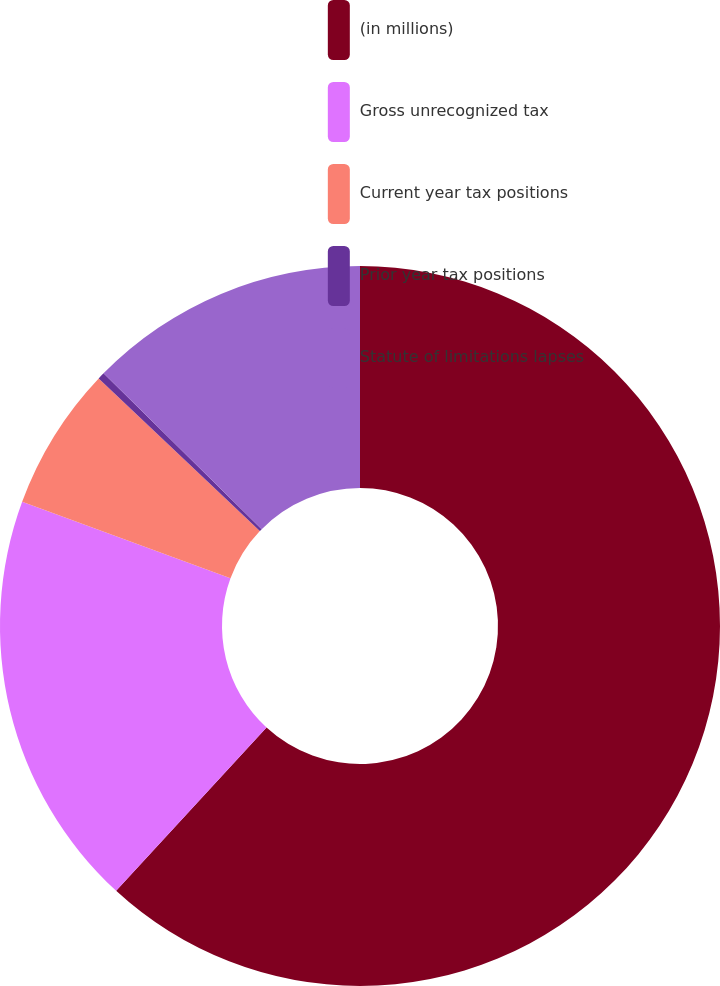Convert chart to OTSL. <chart><loc_0><loc_0><loc_500><loc_500><pie_chart><fcel>(in millions)<fcel>Gross unrecognized tax<fcel>Current year tax positions<fcel>Prior year tax positions<fcel>Statute of limitations lapses<nl><fcel>61.85%<fcel>18.77%<fcel>6.46%<fcel>0.31%<fcel>12.62%<nl></chart> 